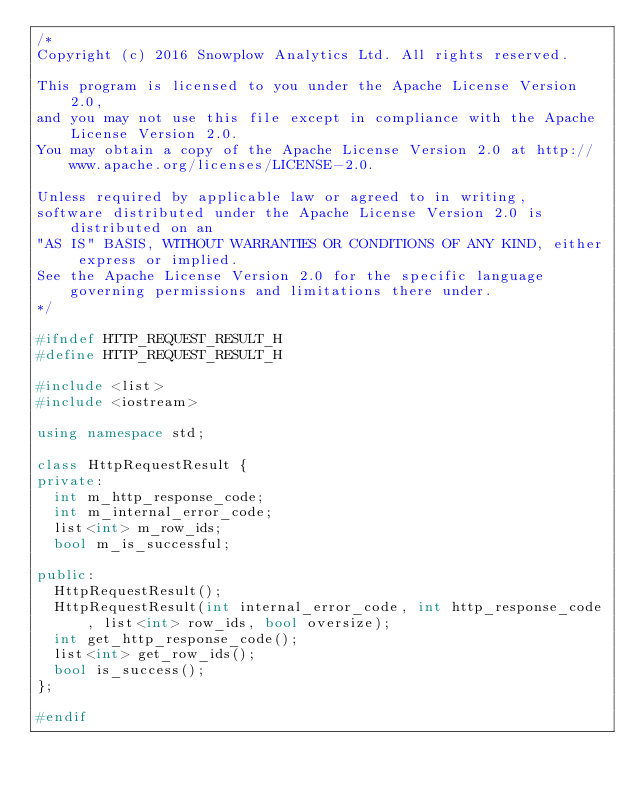<code> <loc_0><loc_0><loc_500><loc_500><_C++_>/*
Copyright (c) 2016 Snowplow Analytics Ltd. All rights reserved.

This program is licensed to you under the Apache License Version 2.0,
and you may not use this file except in compliance with the Apache License Version 2.0.
You may obtain a copy of the Apache License Version 2.0 at http://www.apache.org/licenses/LICENSE-2.0.

Unless required by applicable law or agreed to in writing,
software distributed under the Apache License Version 2.0 is distributed on an
"AS IS" BASIS, WITHOUT WARRANTIES OR CONDITIONS OF ANY KIND, either express or implied.
See the Apache License Version 2.0 for the specific language governing permissions and limitations there under.
*/

#ifndef HTTP_REQUEST_RESULT_H
#define HTTP_REQUEST_RESULT_H

#include <list>
#include <iostream>

using namespace std;

class HttpRequestResult {
private:
  int m_http_response_code;
  int m_internal_error_code;
  list<int> m_row_ids;
  bool m_is_successful;

public:
  HttpRequestResult();
  HttpRequestResult(int internal_error_code, int http_response_code, list<int> row_ids, bool oversize);
  int get_http_response_code();
  list<int> get_row_ids();
  bool is_success();
};

#endif
</code> 